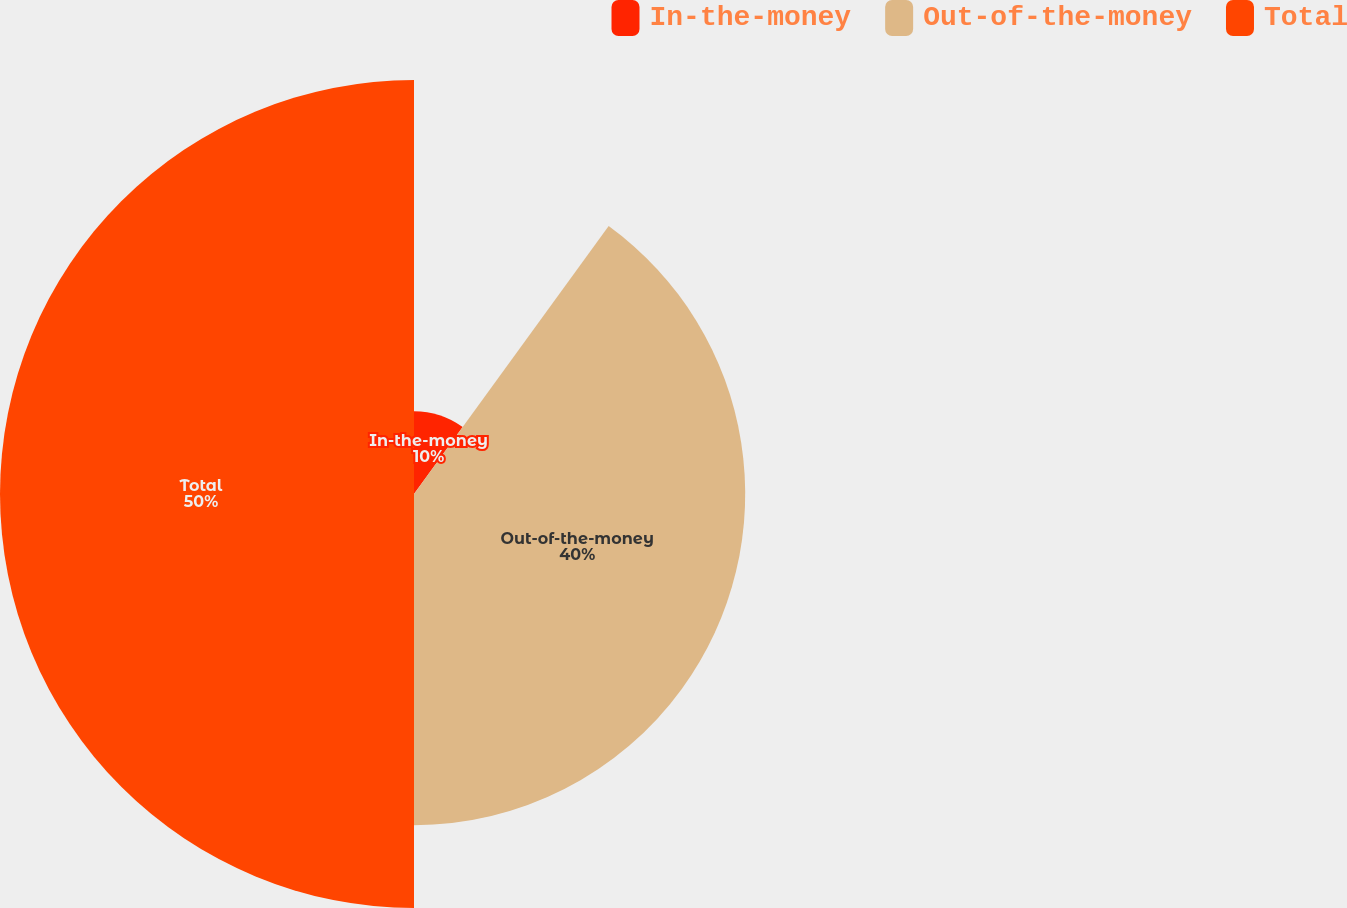<chart> <loc_0><loc_0><loc_500><loc_500><pie_chart><fcel>In-the-money<fcel>Out-of-the-money<fcel>Total<nl><fcel>10.0%<fcel>40.0%<fcel>50.0%<nl></chart> 